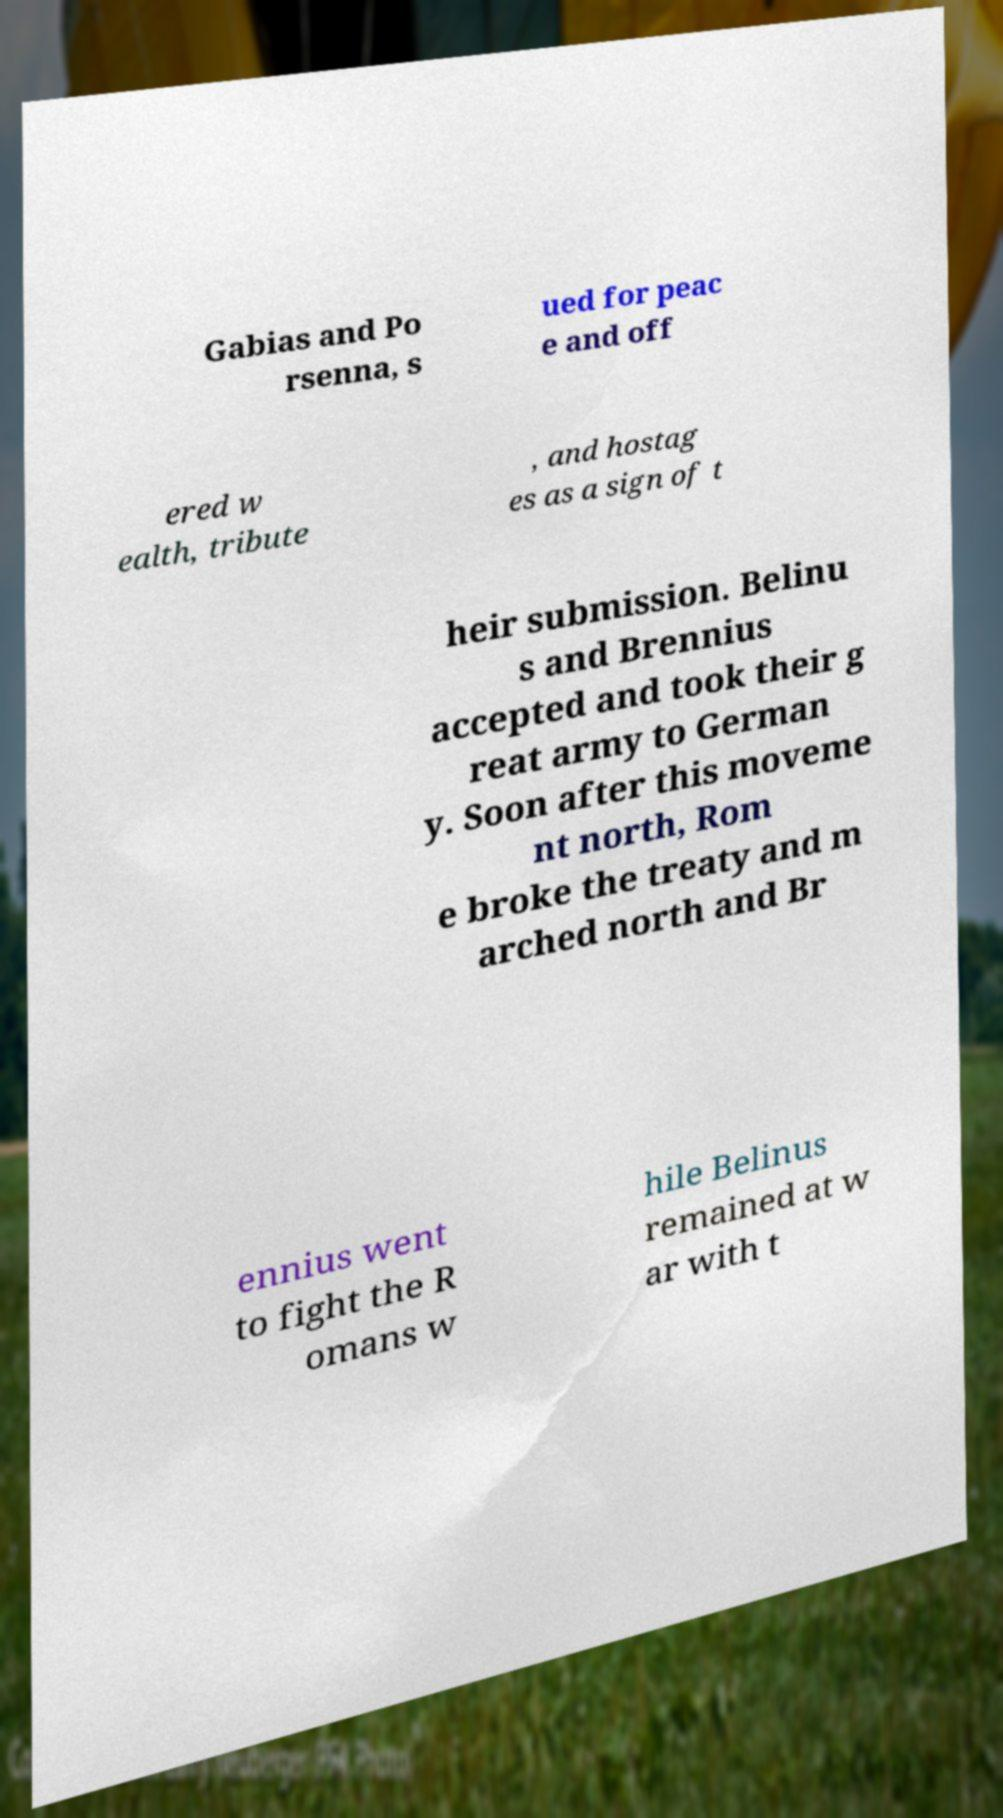For documentation purposes, I need the text within this image transcribed. Could you provide that? Gabias and Po rsenna, s ued for peac e and off ered w ealth, tribute , and hostag es as a sign of t heir submission. Belinu s and Brennius accepted and took their g reat army to German y. Soon after this moveme nt north, Rom e broke the treaty and m arched north and Br ennius went to fight the R omans w hile Belinus remained at w ar with t 